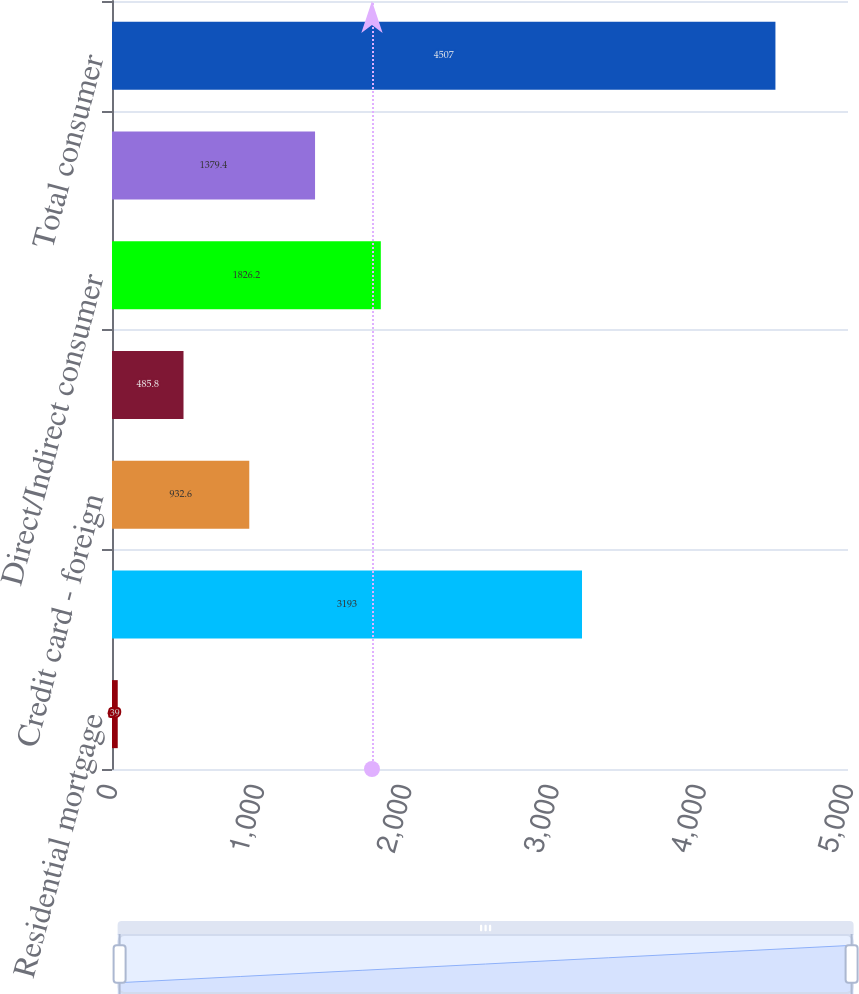<chart> <loc_0><loc_0><loc_500><loc_500><bar_chart><fcel>Residential mortgage<fcel>Credit card - domestic<fcel>Credit card - foreign<fcel>Home equity lines<fcel>Direct/Indirect consumer<fcel>Other consumer<fcel>Total consumer<nl><fcel>39<fcel>3193<fcel>932.6<fcel>485.8<fcel>1826.2<fcel>1379.4<fcel>4507<nl></chart> 